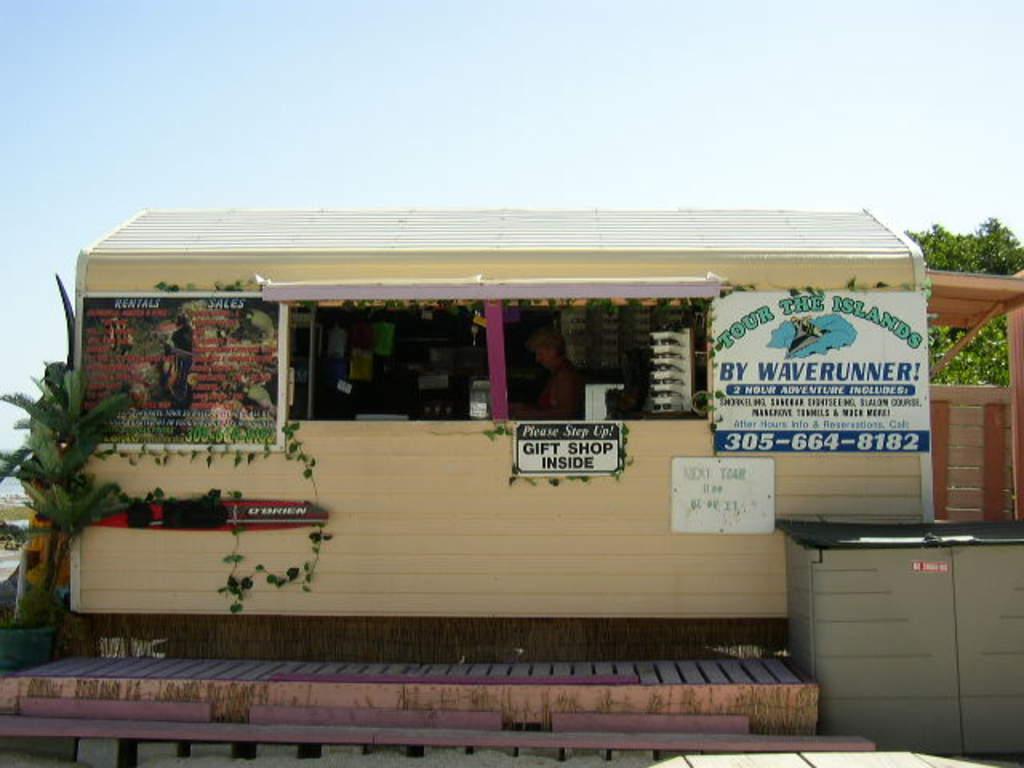Can you describe this image briefly? This picture is clicked outside. In the foreground we can see the stand and there is an object placed on the ground. On the left we can see the pot and a plant. In the center there is a cabin containing some items and there is a person in the cabin seems to be standing on the ground and we can see the banners on which the text is printed. In the background there is a wooden gate, sky and a tree. 